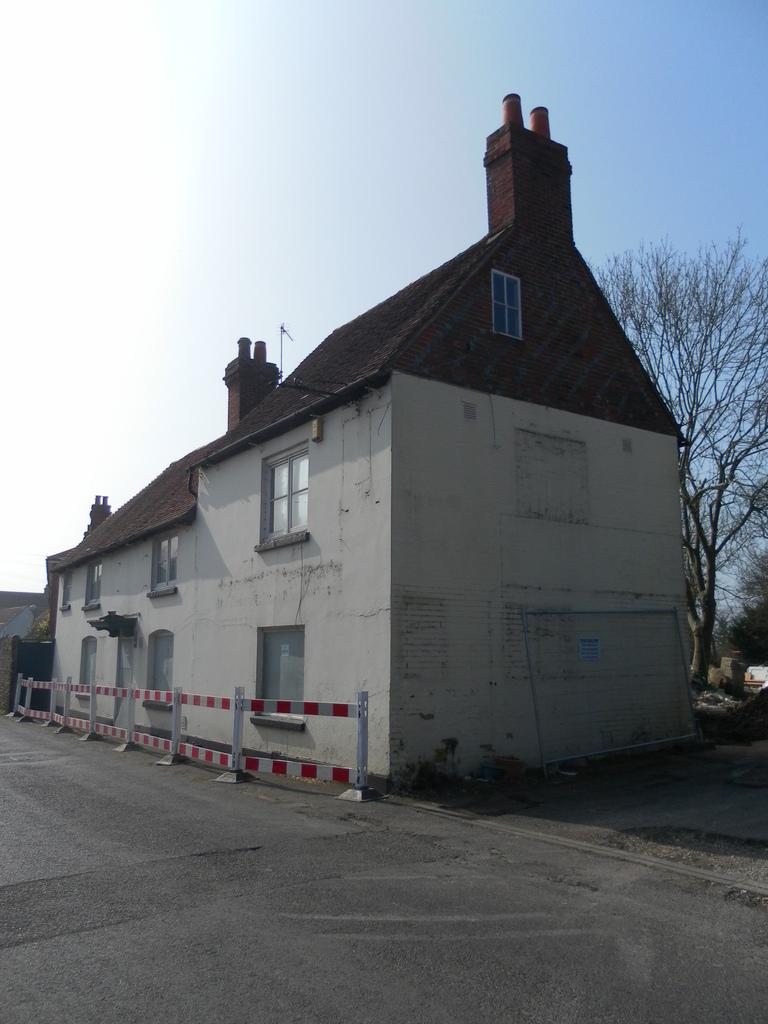What type of structure is in the image? There is a building in the image. What feature of the building can be seen in the image? There are windows visible in the image. What else can be seen in the image besides the building? There is a road, dried trees, metal fencing, and the sky visible in the image. Can you tell me how many berries are on the grandfather's basket in the image? There is no grandfather or basket with berries present in the image. 